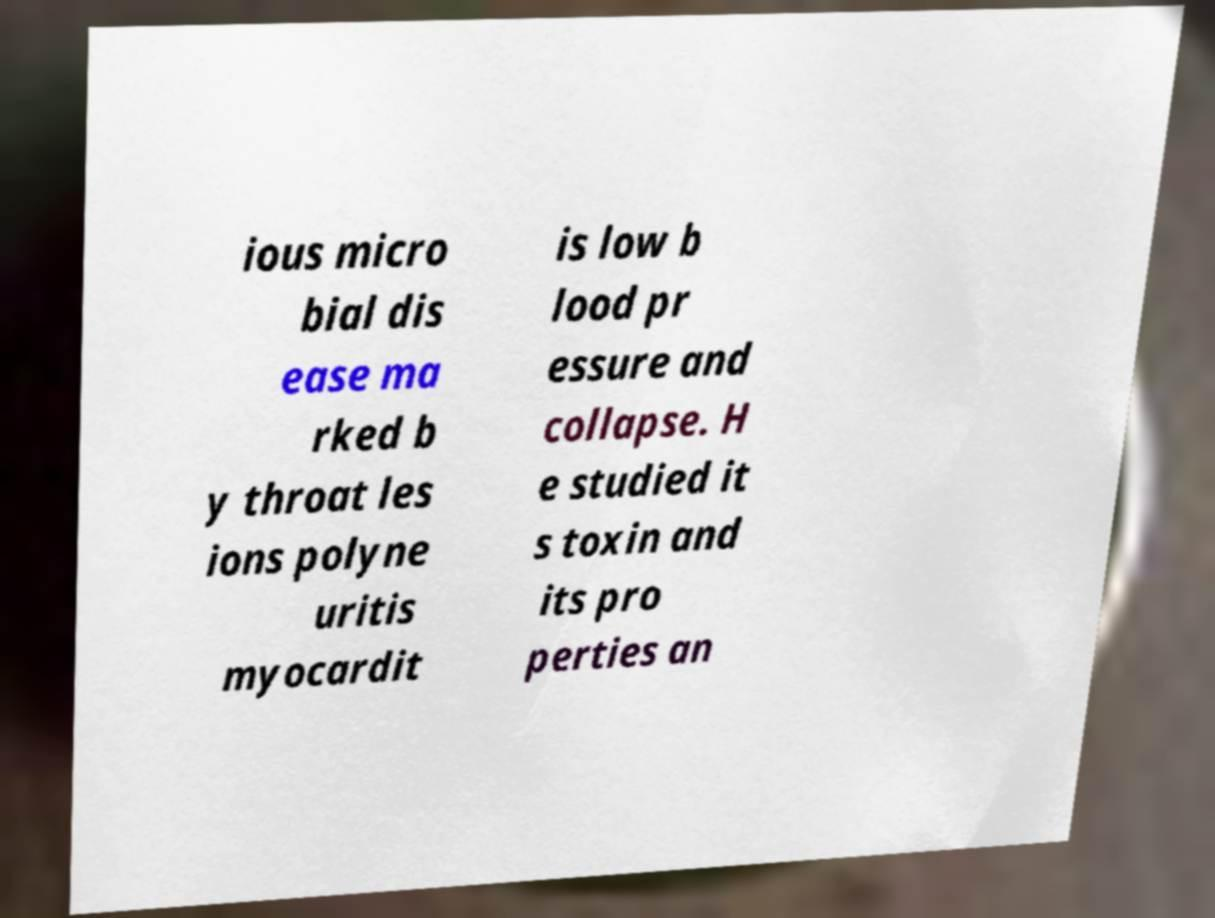Could you assist in decoding the text presented in this image and type it out clearly? ious micro bial dis ease ma rked b y throat les ions polyne uritis myocardit is low b lood pr essure and collapse. H e studied it s toxin and its pro perties an 